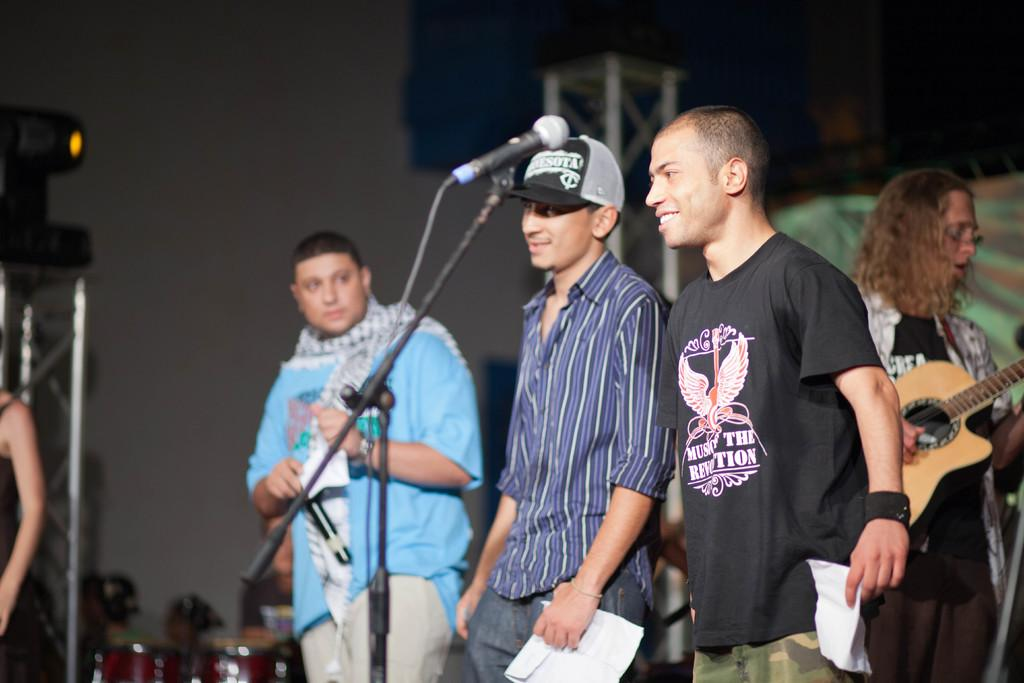How many people are present in the image? There are five people standing in the image. What object can be seen in the image that is typically used for amplifying sound? There is a microphone in the image. What type of structure is visible in the image? There is a stand in the image. What type of humor can be seen in the image? There is no humor present in the image; it features five people, a microphone, and a stand. What type of dinner is being served in the image? There is no dinner present in the image; it features five people, a microphone, and a stand. 